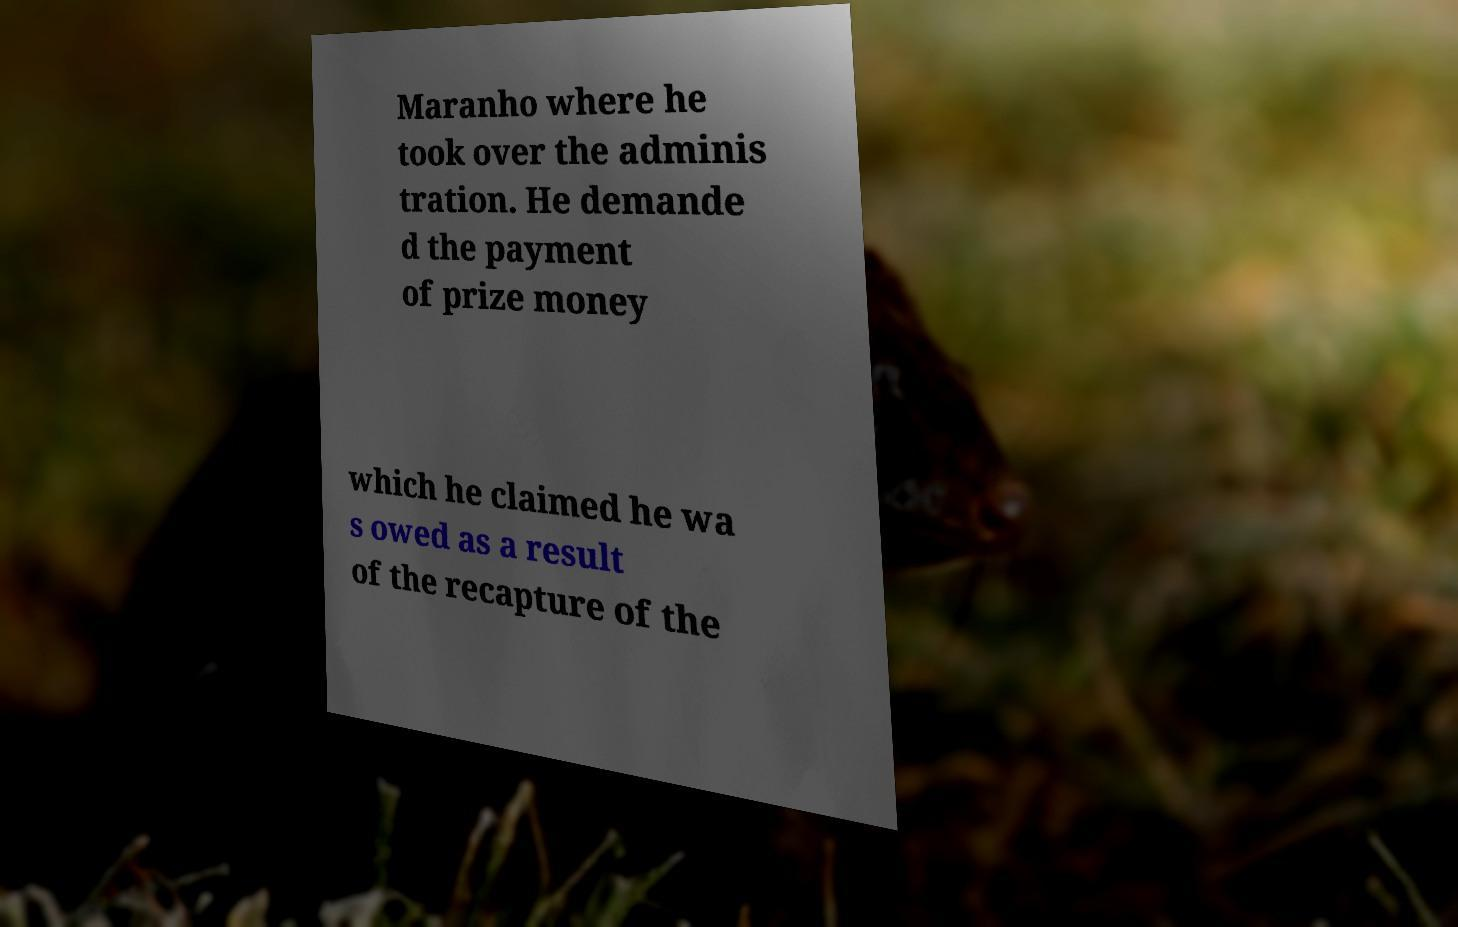Can you read and provide the text displayed in the image?This photo seems to have some interesting text. Can you extract and type it out for me? Maranho where he took over the adminis tration. He demande d the payment of prize money which he claimed he wa s owed as a result of the recapture of the 